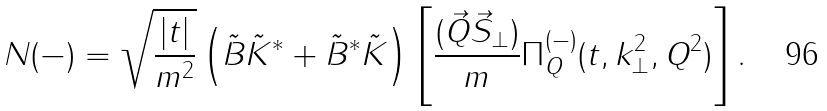Convert formula to latex. <formula><loc_0><loc_0><loc_500><loc_500>N ( - ) = \sqrt { \frac { | t | } { m ^ { 2 } } } \left ( \tilde { B } \tilde { K } ^ { * } + \tilde { B } ^ { * } \tilde { K } \right ) \left [ \frac { ( \vec { Q } \vec { S } _ { \perp } ) } { m } \Pi _ { Q } ^ { ( - ) } ( t , k _ { \perp } ^ { 2 } , Q ^ { 2 } ) \right ] .</formula> 